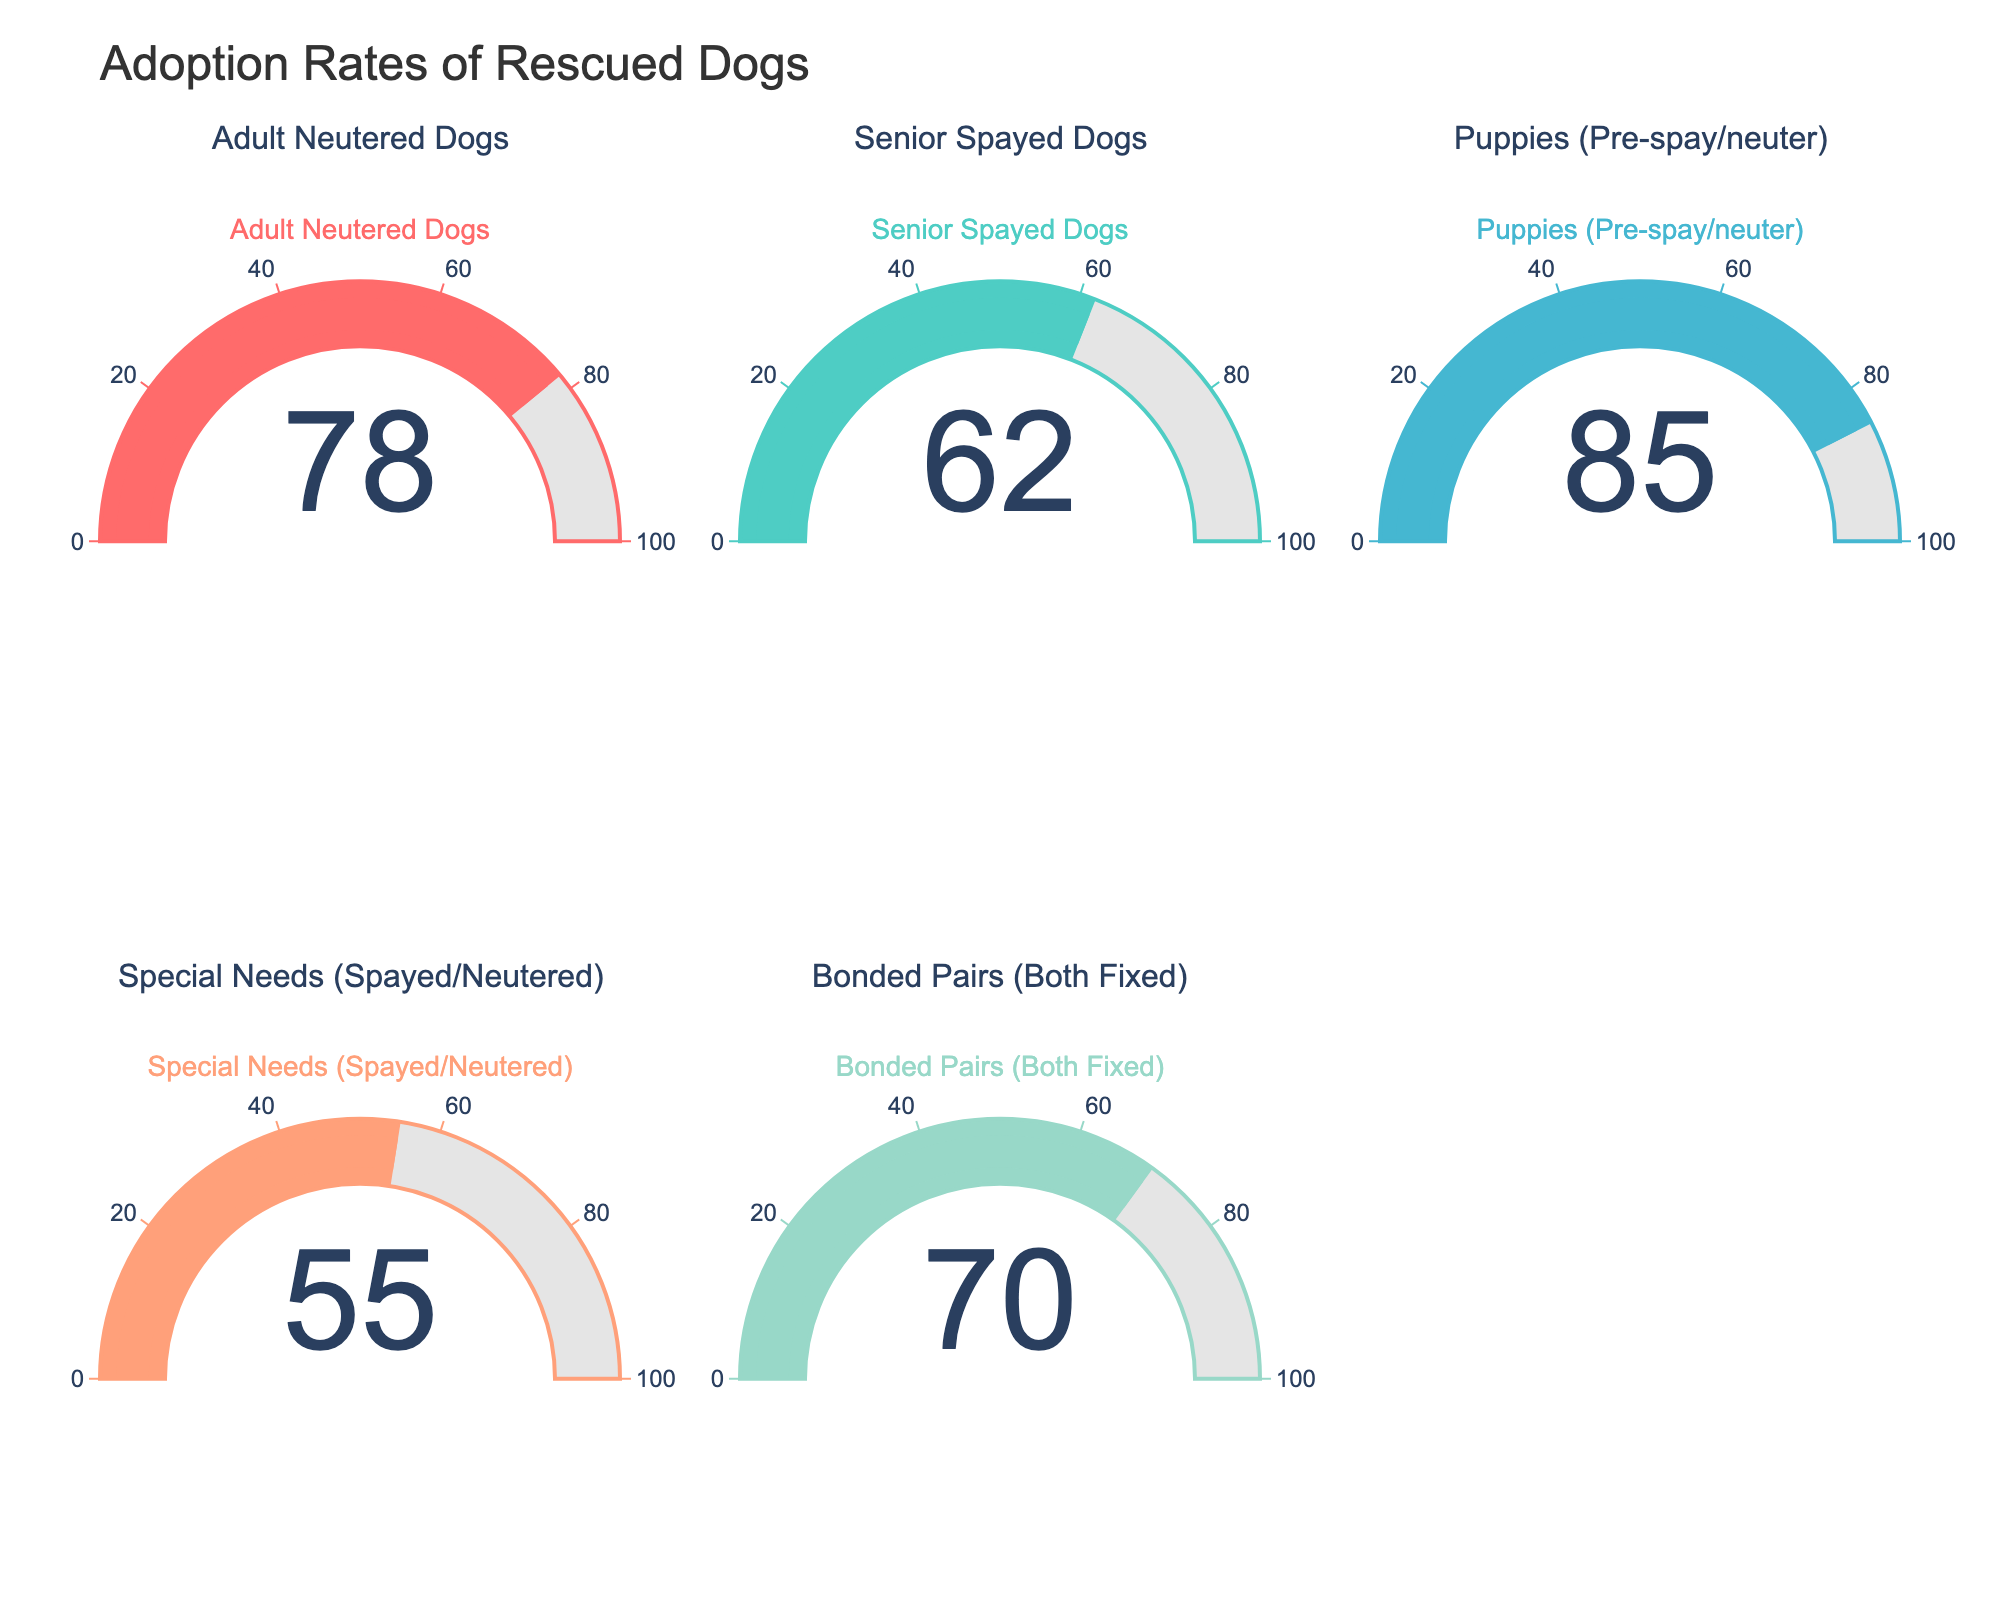What percentage of adult neutered dogs have been adopted? To find the adoption rate for adult neutered dogs, look for the gauge labeled "Adult Neutered Dogs" and read the number displayed.
Answer: 78% What is the adoption rate for senior spayed dogs? To get the adoption rate for senior spayed dogs, check the gauge labeled "Senior Spayed Dogs" and read the percentage shown.
Answer: 62% Which category has the highest adoption rate? Compare the numbers displayed in each gauge. The category with the largest number has the highest adoption rate.
Answer: Puppies (Pre-spay/neuter) Which category shows the lowest adoption rate? Compare the numbers on each gauge; the smallest number indicates the lowest adoption rate.
Answer: Special Needs (Spayed/Neutered) By how much does the adoption rate of puppies exceed that of senior spayed dogs? Subtract the adoption rate of senior spayed dogs from the adoption rate of puppies: 85% - 62%.
Answer: 23% What is the average adoption rate across all categories? To find the average, add up all the adoption rates and divide by the number of categories: (78 + 62 + 85 + 55 + 70) / 5.
Answer: 70% Which types of dogs have an adoption rate exceeding 70%? Identify the gauges with values greater than 70%.
Answer: Adult Neutered Dogs, Puppies (Pre-spay/neuter), Bonded Pairs (Both Fixed) Is the adoption rate for bonded pairs higher than or equal to special needs dogs? Compare the adoption rates of bonded pairs and special needs dogs.
Answer: Higher What's the difference in adoption rates between the highest and lowest categories? Subtract the lowest adoption rate from the highest: 85% - 55%.
Answer: 30% How many categories have an adoption rate above the overall average? First, find the average adoption rate (70%) and count the gauges with adoption rates higher than this value.
Answer: 2 